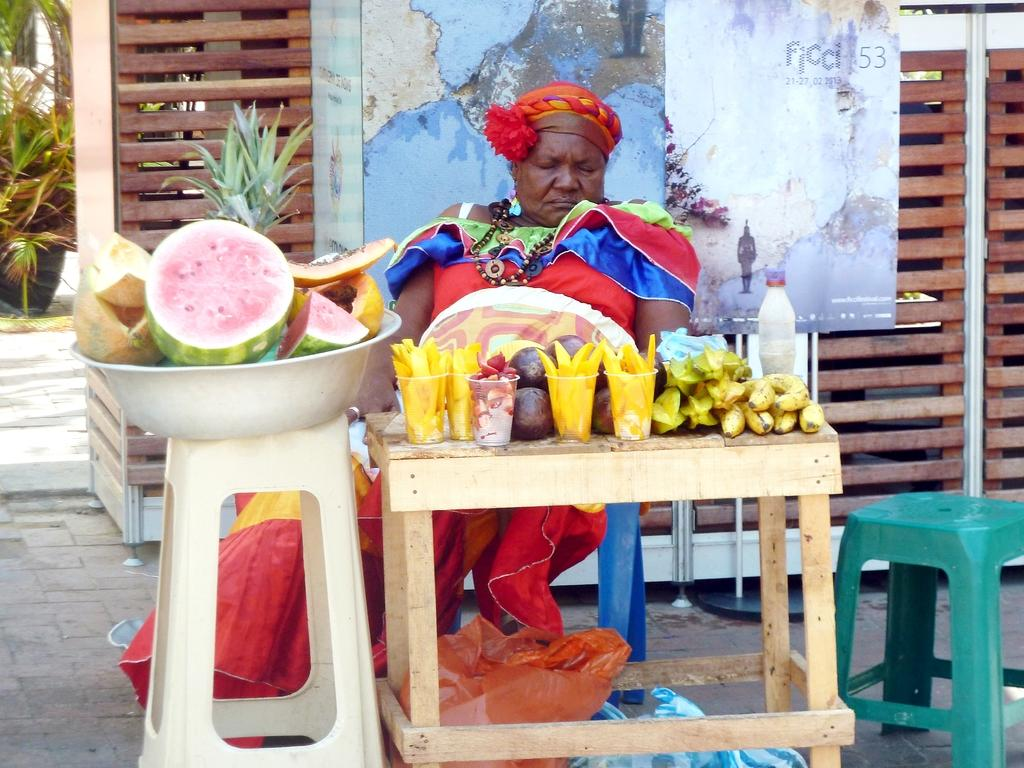What is the person in the image doing? The person is sitting on a chair. What is located near the person? There is a table in the image. What items can be seen on the table? There are glasses, a bottle, and fruits on the table. What can be seen in the background of the image? There is a poster, plants, and a fence in the background. What type of pin is holding the poster to the wall in the image? There is no pin visible in the image; the poster is not mentioned as being attached to the wall. 